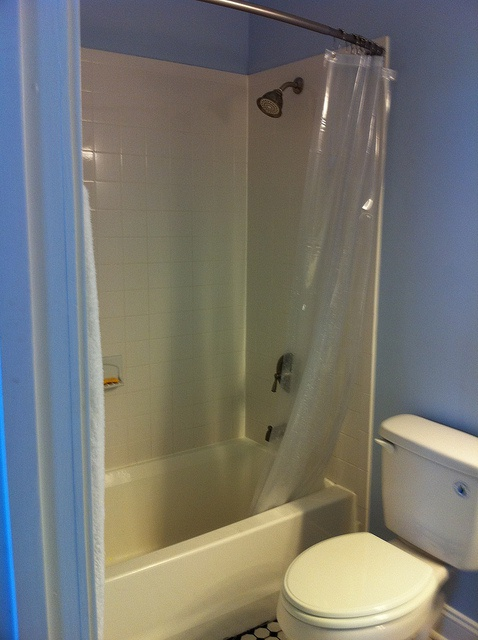Describe the objects in this image and their specific colors. I can see a toilet in blue, khaki, and gray tones in this image. 